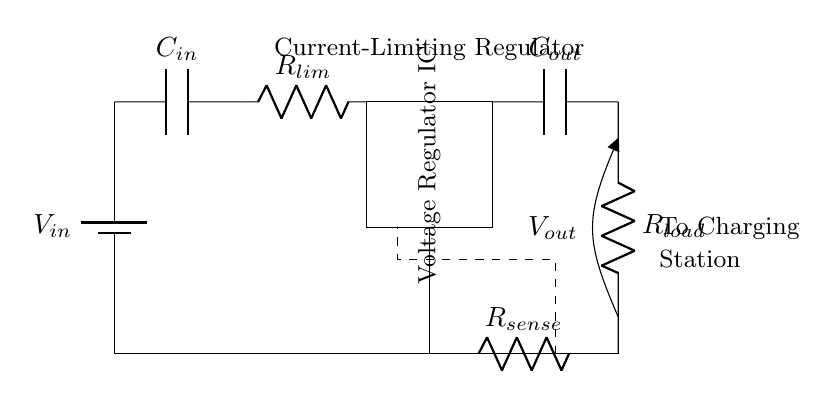What is the input voltage of this circuit? The input voltage is denoted as V_in, which is represented by the battery in the circuit diagram.
Answer: V_in What is the purpose of the current-limiting resistor? The current-limiting resistor, R_lim, is used to restrict the amount of current flowing into the circuit to protect sensitive components, specifically during charging.
Answer: To protect sensitive components What component controls the output voltage? The component that controls the output voltage is the voltage regulator IC, which ensures a stable output voltage regardless of variations in input voltage or load conditions.
Answer: Voltage regulator IC How many capacitors are present in this circuit? There are two capacitors in the circuit: C_in and C_out, which are used for input stabilization and output smoothing, respectively.
Answer: Two What is the role of the sense resistor? The sense resistor, R_sense, is used to monitor the current flowing through the circuit and is part of the feedback mechanism for the voltage regulator.
Answer: Monitor current If the load resistor has a value of 10 ohms, how will the voltage across it relate to the output voltage? The voltage across the load resistor, R_load, will be equal to the output voltage, V_out, as they are directly connected in parallel to the output of the voltage regulator.
Answer: Equal to V_out What does the feedback connection indicate in this circuit? The feedback connection indicates that the circuit uses negative feedback to regulate the output voltage by comparing the output with a reference value, adjusting the regulator as necessary.
Answer: Negative feedback for regulation 